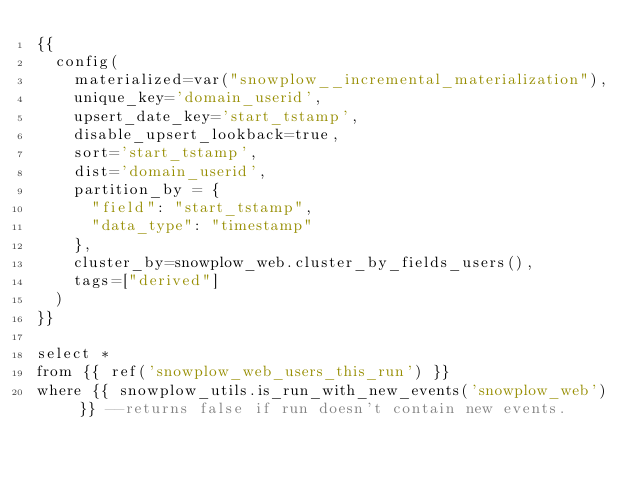<code> <loc_0><loc_0><loc_500><loc_500><_SQL_>{{ 
  config(
    materialized=var("snowplow__incremental_materialization"),
    unique_key='domain_userid',
    upsert_date_key='start_tstamp',
    disable_upsert_lookback=true,
    sort='start_tstamp',
    dist='domain_userid',
    partition_by = {
      "field": "start_tstamp",
      "data_type": "timestamp"
    },
    cluster_by=snowplow_web.cluster_by_fields_users(),
    tags=["derived"]
  ) 
}}

select * 
from {{ ref('snowplow_web_users_this_run') }}
where {{ snowplow_utils.is_run_with_new_events('snowplow_web') }} --returns false if run doesn't contain new events.
</code> 